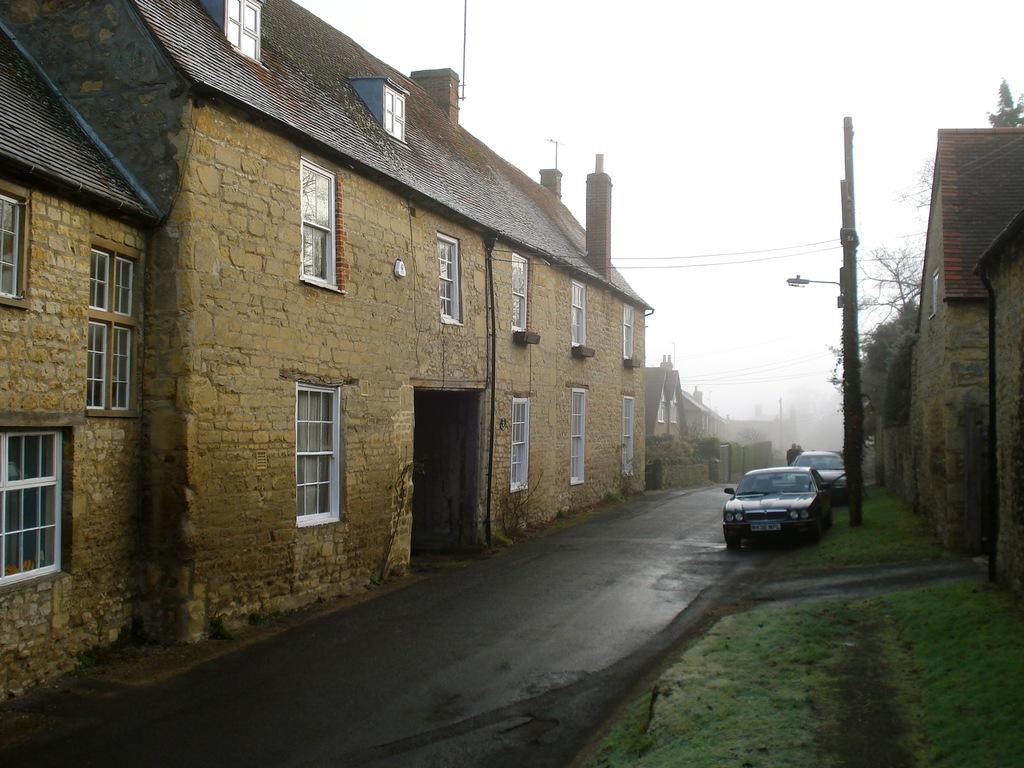What structures are located on both sides of the image? There are buildings on either side of the image. What can be seen in the middle of the image? There are vehicles on the road in the middle of the image. What is visible at the top of the image? The sky is visible at the top of the image. What is the cause of the horses running in the image? There are no horses present in the image; it features buildings, vehicles, and the sky. What scale is used to depict the buildings in the image? The image does not provide information about the scale used to depict the buildings. 